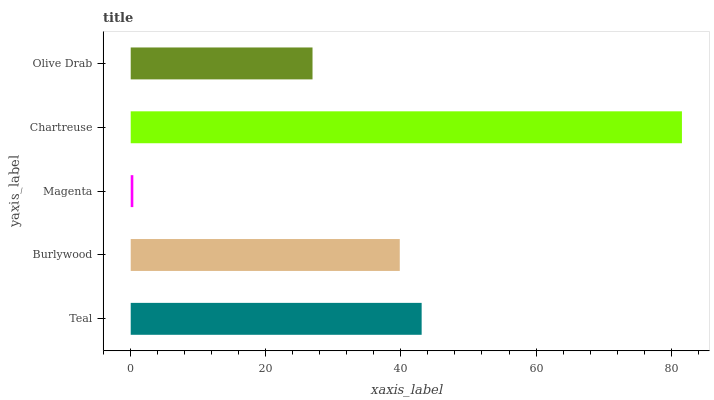Is Magenta the minimum?
Answer yes or no. Yes. Is Chartreuse the maximum?
Answer yes or no. Yes. Is Burlywood the minimum?
Answer yes or no. No. Is Burlywood the maximum?
Answer yes or no. No. Is Teal greater than Burlywood?
Answer yes or no. Yes. Is Burlywood less than Teal?
Answer yes or no. Yes. Is Burlywood greater than Teal?
Answer yes or no. No. Is Teal less than Burlywood?
Answer yes or no. No. Is Burlywood the high median?
Answer yes or no. Yes. Is Burlywood the low median?
Answer yes or no. Yes. Is Magenta the high median?
Answer yes or no. No. Is Olive Drab the low median?
Answer yes or no. No. 